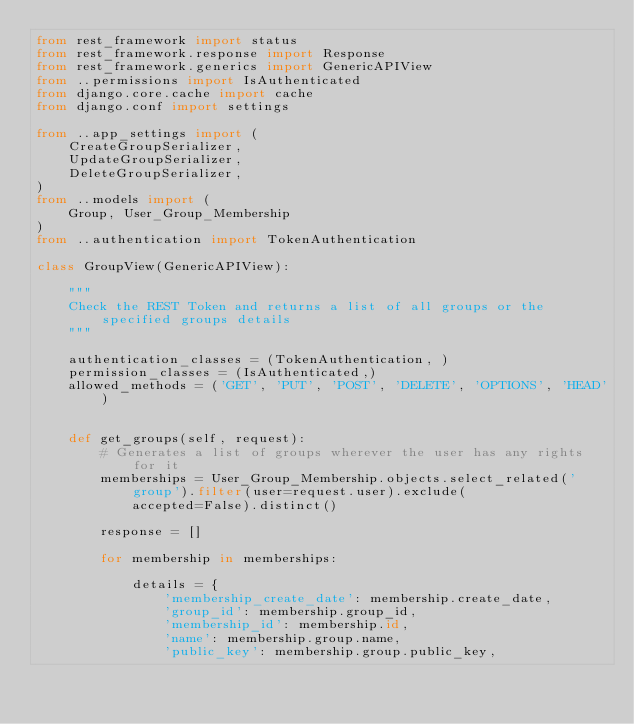Convert code to text. <code><loc_0><loc_0><loc_500><loc_500><_Python_>from rest_framework import status
from rest_framework.response import Response
from rest_framework.generics import GenericAPIView
from ..permissions import IsAuthenticated
from django.core.cache import cache
from django.conf import settings

from ..app_settings import (
    CreateGroupSerializer,
    UpdateGroupSerializer,
    DeleteGroupSerializer,
)
from ..models import (
    Group, User_Group_Membership
)
from ..authentication import TokenAuthentication

class GroupView(GenericAPIView):

    """
    Check the REST Token and returns a list of all groups or the specified groups details
    """

    authentication_classes = (TokenAuthentication, )
    permission_classes = (IsAuthenticated,)
    allowed_methods = ('GET', 'PUT', 'POST', 'DELETE', 'OPTIONS', 'HEAD')


    def get_groups(self, request):
        # Generates a list of groups wherever the user has any rights for it
        memberships = User_Group_Membership.objects.select_related('group').filter(user=request.user).exclude(
            accepted=False).distinct()

        response = []

        for membership in memberships:

            details = {
                'membership_create_date': membership.create_date,
                'group_id': membership.group_id,
                'membership_id': membership.id,
                'name': membership.group.name,
                'public_key': membership.group.public_key,</code> 